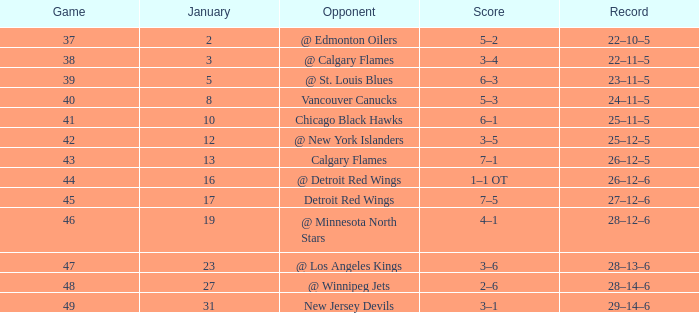How many games feature a scoreline of 2-6 and a total point count greater than 62? 0.0. 